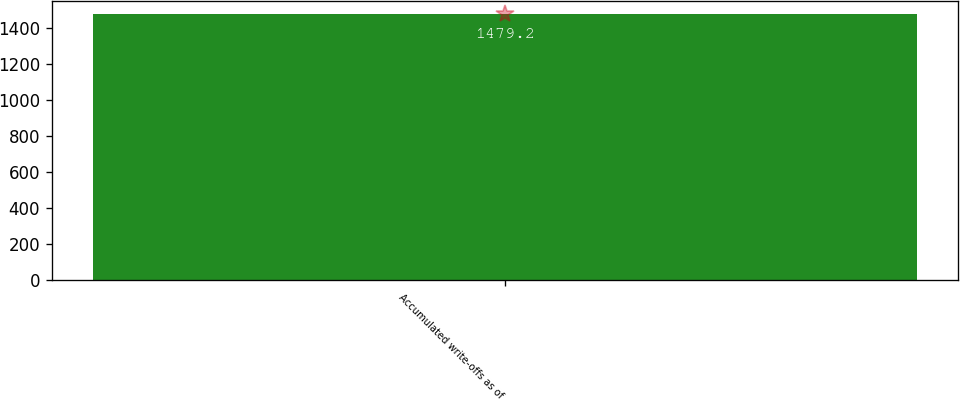Convert chart. <chart><loc_0><loc_0><loc_500><loc_500><bar_chart><fcel>Accumulated write-offs as of<nl><fcel>1479.2<nl></chart> 